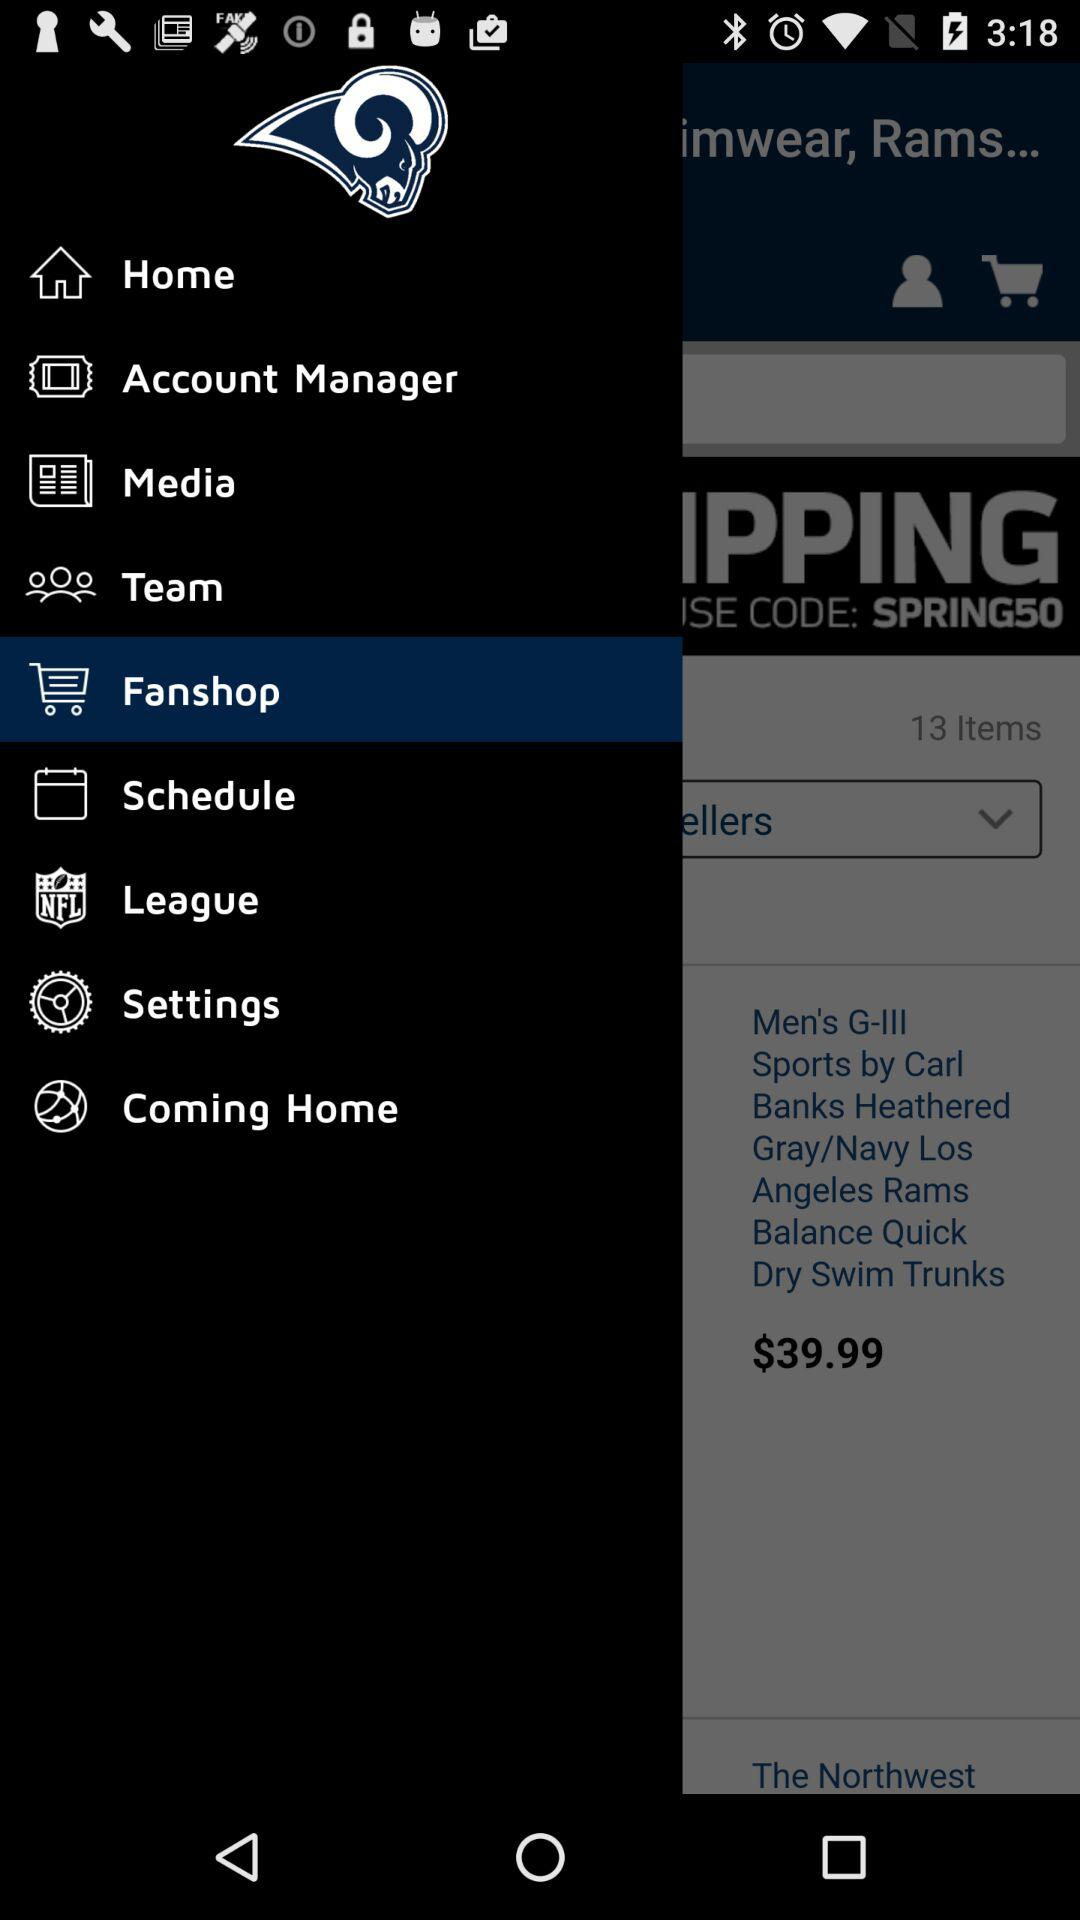How many items are in the cart?
Answer the question using a single word or phrase. 13 